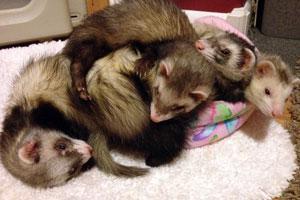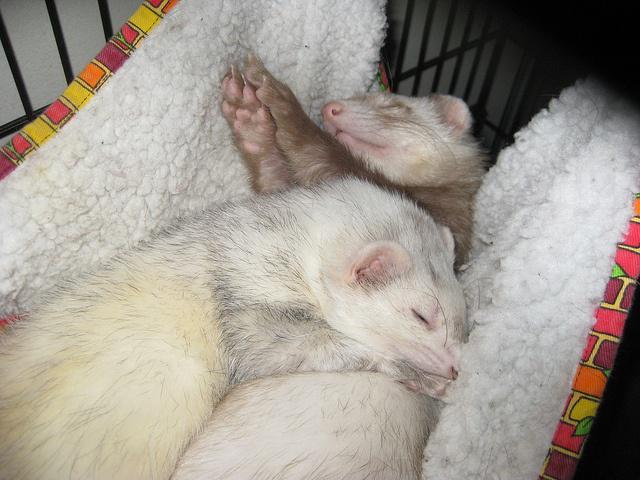The first image is the image on the left, the second image is the image on the right. Assess this claim about the two images: "There are exactly four ferrets.". Correct or not? Answer yes or no. No. 